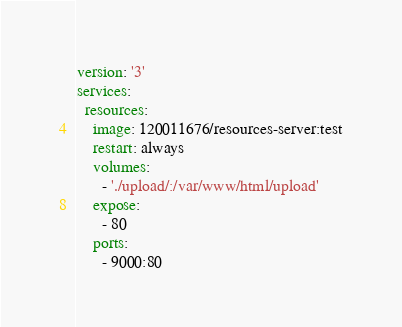Convert code to text. <code><loc_0><loc_0><loc_500><loc_500><_YAML_>version: '3'
services:
  resources:
    image: 120011676/resources-server:test
    restart: always
    volumes:
      - './upload/:/var/www/html/upload'
    expose:
      - 80
    ports:
      - 9000:80</code> 